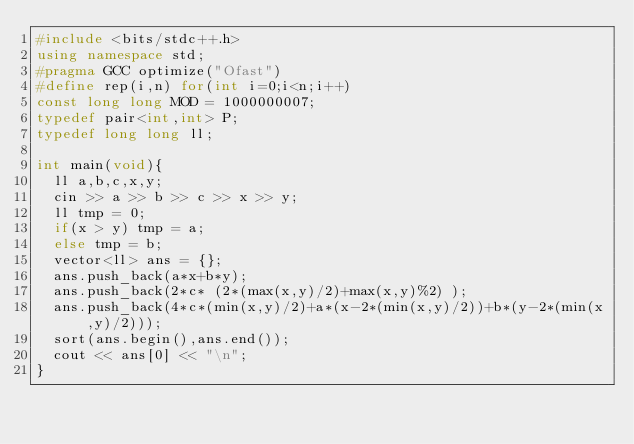Convert code to text. <code><loc_0><loc_0><loc_500><loc_500><_C++_>#include <bits/stdc++.h>
using namespace std;
#pragma GCC optimize("Ofast")
#define rep(i,n) for(int i=0;i<n;i++)
const long long MOD = 1000000007;
typedef pair<int,int> P;
typedef long long ll;

int main(void){
  ll a,b,c,x,y;
  cin >> a >> b >> c >> x >> y;
  ll tmp = 0;
  if(x > y) tmp = a;
  else tmp = b;
  vector<ll> ans = {};
  ans.push_back(a*x+b*y);
  ans.push_back(2*c* (2*(max(x,y)/2)+max(x,y)%2) );
  ans.push_back(4*c*(min(x,y)/2)+a*(x-2*(min(x,y)/2))+b*(y-2*(min(x,y)/2)));
  sort(ans.begin(),ans.end());
  cout << ans[0] << "\n";
}</code> 